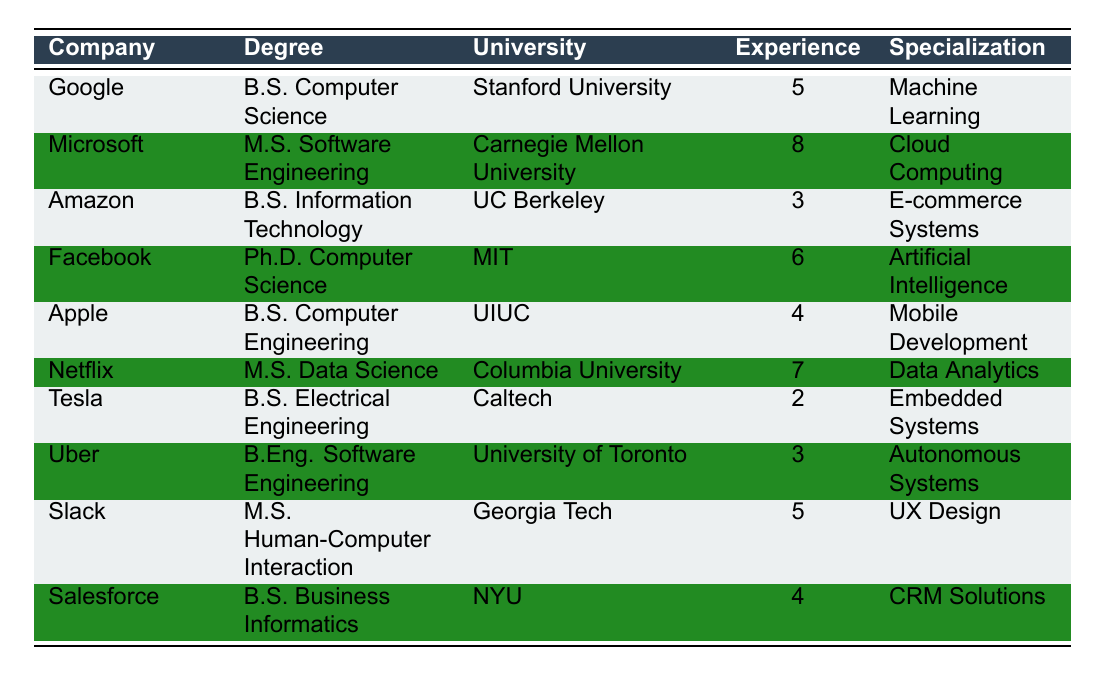What is the degree obtained by the software engineer at Google? The table shows that the software engineer at Google obtained a Bachelor of Science in Computer Science.
Answer: Bachelor of Science in Computer Science Which university did the Microsoft engineer attend? According to the table, the Microsoft engineer attended Carnegie Mellon University.
Answer: Carnegie Mellon University How many years of experience does the engineer from Netflix have? The table indicates that the engineer from Netflix has 7 years of experience.
Answer: 7 True or False: The engineer at Tesla has more than 5 years of experience. The table shows that the engineer at Tesla has only 2 years of experience, which is less than 5.
Answer: False Which specialization is associated with the employee at Facebook? The table states that the specialization for the employee at Facebook is Artificial Intelligence.
Answer: Artificial Intelligence What is the average years of experience of software engineers listed in the table? There are 10 data points and the total years of experience are 5 + 8 + 3 + 6 + 4 + 7 + 2 + 3 + 5 + 4 = 43 years. Therefore, the average is 43/10 = 4.3.
Answer: 4.3 How many engineers have degrees in Software Engineering or related fields? The table lists two engineers with degrees in related fields: one with a Bachelor of Engineering in Software Engineering at Uber and another with a Master of Science in Software Engineering at Microsoft. Thus, there are 2 engineers.
Answer: 2 What is the specialization of the employee with the highest years of experience? The employee with the highest years of experience is at Microsoft with 8 years and has a specialization in Cloud Computing.
Answer: Cloud Computing Which companies have engineers with a degree in Computer Science? According to the table, Google and Facebook have engineers with degrees in Computer Science, specifically Bachelor and Ph.D. respectively.
Answer: Google, Facebook 